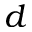<formula> <loc_0><loc_0><loc_500><loc_500>d</formula> 